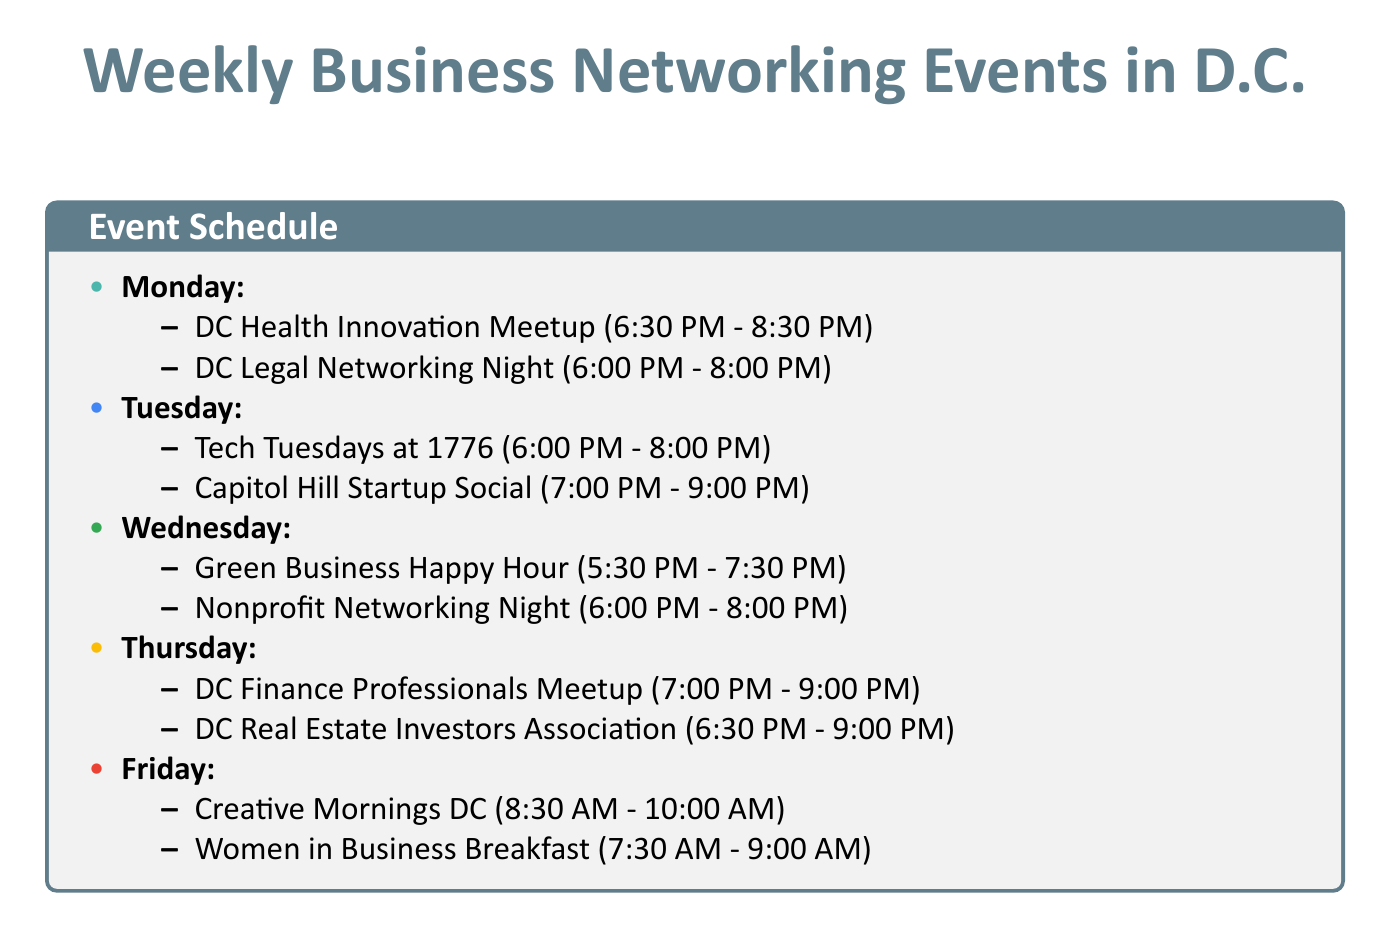What day is the DC Health Innovation Meetup? The document lists the day for the DC Health Innovation Meetup as Monday.
Answer: Monday What is the location for the Women in Business Breakfast? The document provides the location for the Women in Business Breakfast as The Hamilton, 600 14th St NW, Washington, DC 20005.
Answer: The Hamilton, 600 14th St NW, Washington, DC 20005 How long does the Tech Tuesdays at 1776 event last? The document shows that the Tech Tuesdays at 1776 event lasts from 6:00 PM to 8:00 PM, which is two hours.
Answer: 2 hours Which industry does the Green Business Happy Hour belong to? The document categorizes the Green Business Happy Hour under the Environmental & Sustainability industry.
Answer: Environmental & Sustainability How many events occur on Thursdays? The document indicates there are two events listed for Thursdays.
Answer: 2 What type of gathering is the DC Finance Professionals Meetup? The document describes the DC Finance Professionals Meetup as a gathering for finance professionals to discuss market trends and network.
Answer: Gathering for finance professionals What is the color code for the Legal industry events? The document specifies the color code for Legal industry events as #3F51B5.
Answer: #3F51B5 Which event takes place first in the week? The document indicates that the DC Health Innovation Meetup takes place first among the listed events on Mondays.
Answer: DC Health Innovation Meetup What is the description of the Nonprofit Networking Night? The document defines the Nonprofit Networking Night as a networking event for nonprofit professionals, volunteers, and supporters.
Answer: Networking event for nonprofit professionals, volunteers, and supporters 